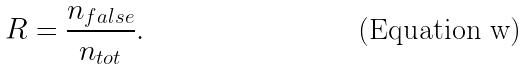Convert formula to latex. <formula><loc_0><loc_0><loc_500><loc_500>R = \frac { n _ { f a l s e } } { n _ { t o t } } .</formula> 